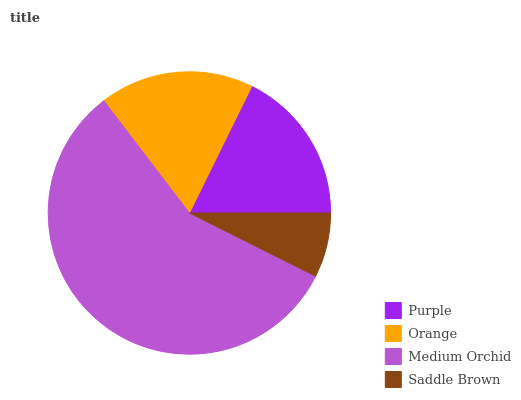Is Saddle Brown the minimum?
Answer yes or no. Yes. Is Medium Orchid the maximum?
Answer yes or no. Yes. Is Orange the minimum?
Answer yes or no. No. Is Orange the maximum?
Answer yes or no. No. Is Purple greater than Orange?
Answer yes or no. Yes. Is Orange less than Purple?
Answer yes or no. Yes. Is Orange greater than Purple?
Answer yes or no. No. Is Purple less than Orange?
Answer yes or no. No. Is Purple the high median?
Answer yes or no. Yes. Is Orange the low median?
Answer yes or no. Yes. Is Orange the high median?
Answer yes or no. No. Is Saddle Brown the low median?
Answer yes or no. No. 